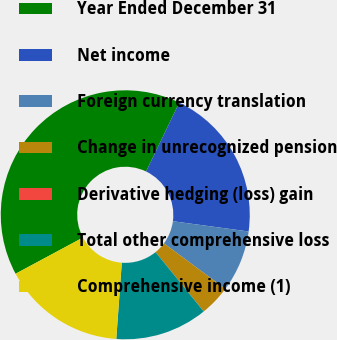Convert chart to OTSL. <chart><loc_0><loc_0><loc_500><loc_500><pie_chart><fcel>Year Ended December 31<fcel>Net income<fcel>Foreign currency translation<fcel>Change in unrecognized pension<fcel>Derivative hedging (loss) gain<fcel>Total other comprehensive loss<fcel>Comprehensive income (1)<nl><fcel>39.99%<fcel>20.0%<fcel>8.0%<fcel>4.0%<fcel>0.01%<fcel>12.0%<fcel>16.0%<nl></chart> 